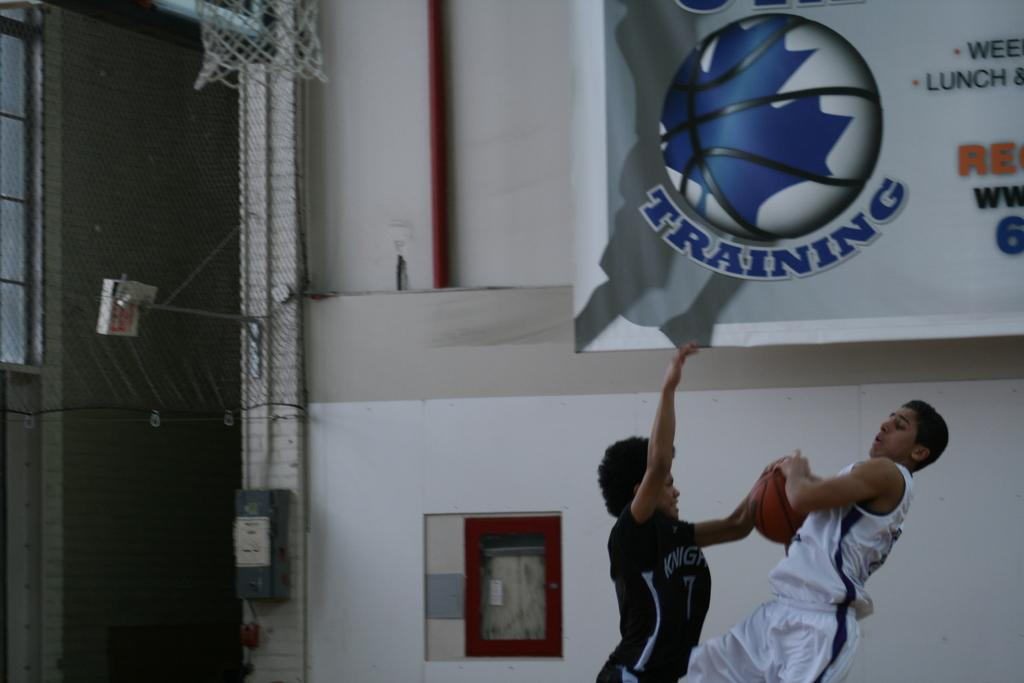How many people are in the image? There are two persons in the image. What are the two persons holding in their hands? The two persons are holding a ball in their hands. What can be seen in the background of the image? There is a banner and a net in the background of the image. Are there any icicles hanging from the net in the image? There are no icicles present in the image. Can you see the two persons swimming in the image? The image does not show the two persons swimming; they are holding a ball. 